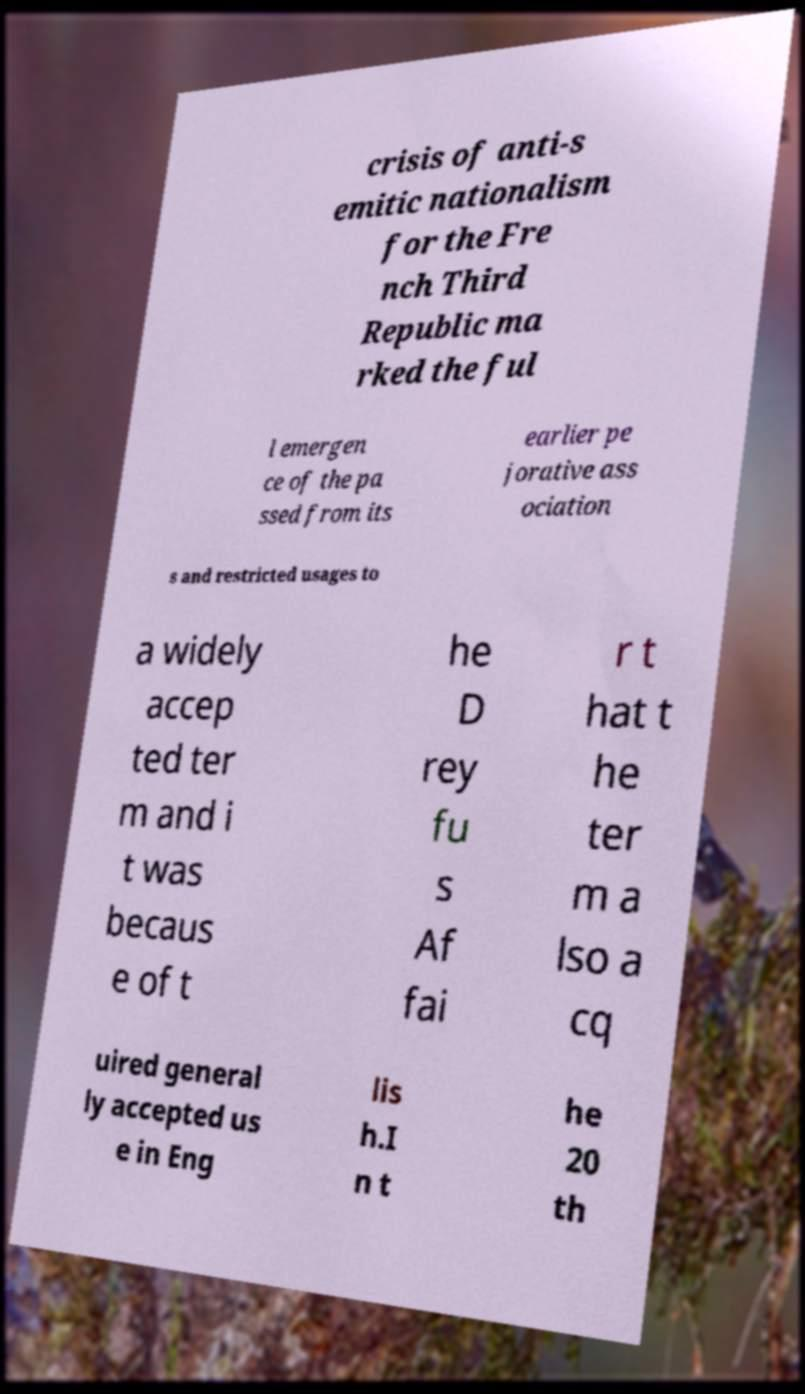Please read and relay the text visible in this image. What does it say? crisis of anti-s emitic nationalism for the Fre nch Third Republic ma rked the ful l emergen ce of the pa ssed from its earlier pe jorative ass ociation s and restricted usages to a widely accep ted ter m and i t was becaus e of t he D rey fu s Af fai r t hat t he ter m a lso a cq uired general ly accepted us e in Eng lis h.I n t he 20 th 